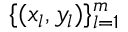Convert formula to latex. <formula><loc_0><loc_0><loc_500><loc_500>\{ ( x _ { l } , y _ { l } ) \} _ { l = 1 } ^ { m }</formula> 